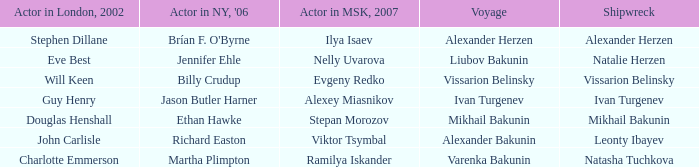Who was the 2007 actor from Moscow for the voyage of Varenka Bakunin? Ramilya Iskander. 